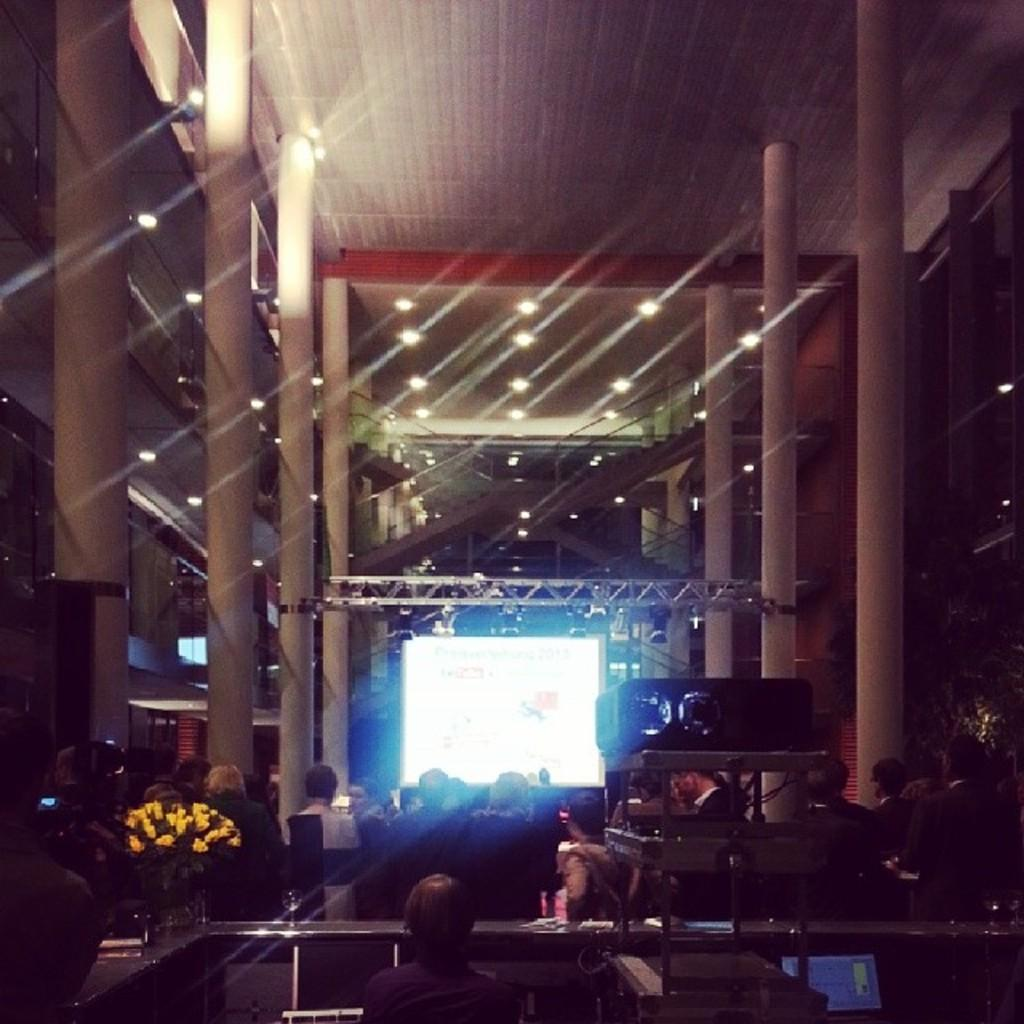Who or what can be seen in the image? There are people in the image. What device is present in the image? There is a projector in the image. What type of decorative elements are visible in the image? There are flowers in the image. What objects are on a table in the image? There are objects on a table in the image. What architectural features can be seen in the image? There are pillars in the image. What is in the background of the image? There is a screen and lights in the background of the image. How many feet of can are present on the earth in the image? There is no reference to cans or feet in the image, so it is not possible to answer that question. 